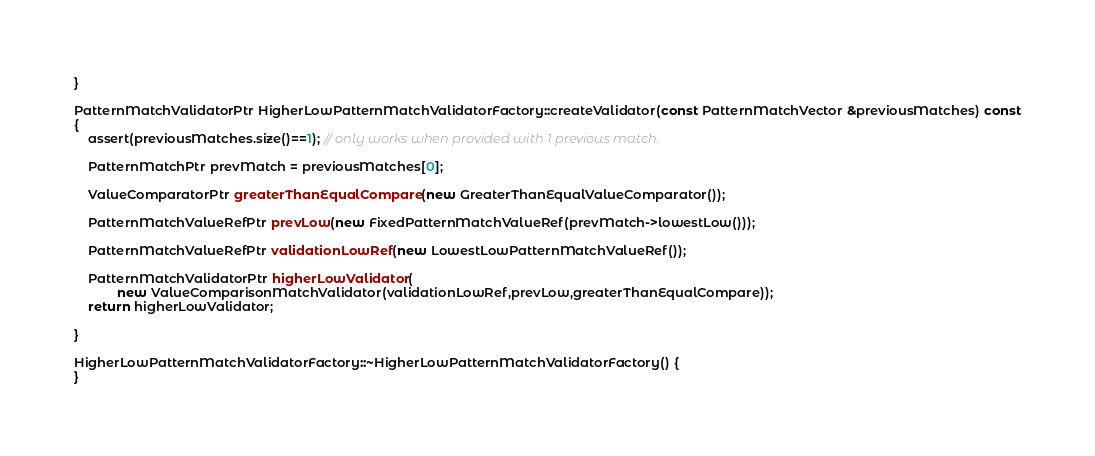<code> <loc_0><loc_0><loc_500><loc_500><_C++_>}

PatternMatchValidatorPtr HigherLowPatternMatchValidatorFactory::createValidator(const PatternMatchVector &previousMatches) const
{
	assert(previousMatches.size()==1); // only works when provided with 1 previous match.

	PatternMatchPtr prevMatch = previousMatches[0];

	ValueComparatorPtr greaterThanEqualCompare(new GreaterThanEqualValueComparator());

	PatternMatchValueRefPtr prevLow(new FixedPatternMatchValueRef(prevMatch->lowestLow()));

	PatternMatchValueRefPtr validationLowRef(new LowestLowPatternMatchValueRef());

	PatternMatchValidatorPtr higherLowValidator(
			new ValueComparisonMatchValidator(validationLowRef,prevLow,greaterThanEqualCompare));
	return higherLowValidator;

}

HigherLowPatternMatchValidatorFactory::~HigherLowPatternMatchValidatorFactory() {
}

</code> 